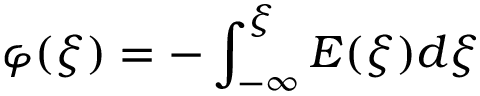Convert formula to latex. <formula><loc_0><loc_0><loc_500><loc_500>\varphi ( \xi ) = - \int _ { - \infty } ^ { \xi } E ( \xi ) d \xi</formula> 